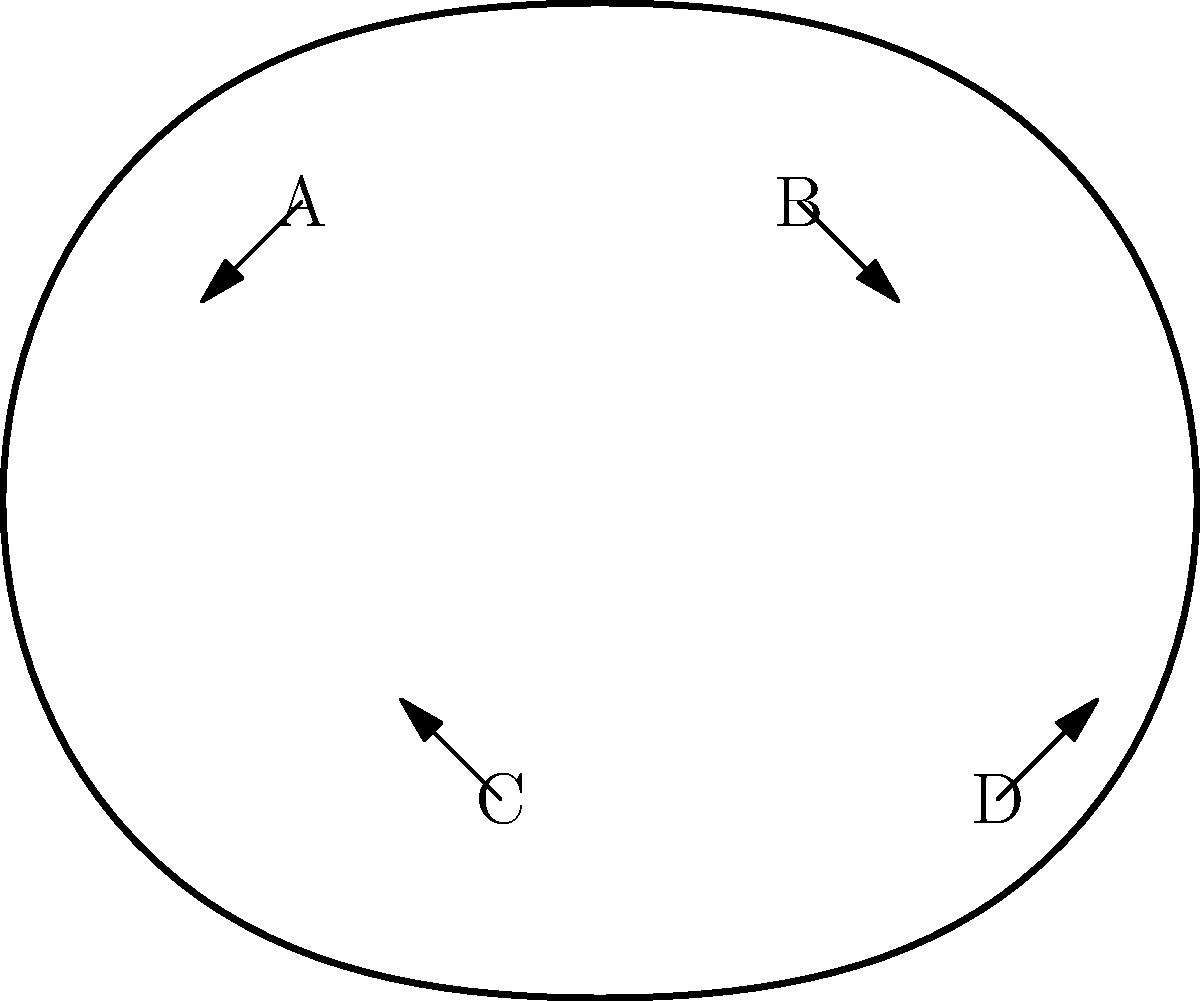Match the following mental health conditions with their associated brain regions in the diagram:

1. Depression
2. Anxiety
3. ADHD
4. Schizophrenia

Which letter (A, B, C, or D) corresponds to the brain region most associated with each condition? To answer this question, let's examine each mental health condition and its associated brain region:

1. Depression: primarily associated with the prefrontal cortex and limbic system, particularly the hippocampus. In the diagram, area A represents the prefrontal cortex.

2. Anxiety: mainly linked to the amygdala, which is part of the limbic system. In the diagram, area C represents the approximate location of the amygdala.

3. ADHD (Attention Deficit Hyperactivity Disorder): associated with the frontal lobe, specifically the prefrontal cortex. This is also represented by area A in the diagram.

4. Schizophrenia: involves multiple brain regions, but significant abnormalities are often found in the temporal lobe. In the diagram, area D represents the temporal lobe.

Step-by-step matching:
1. Depression - A (prefrontal cortex)
2. Anxiety - C (amygdala)
3. ADHD - A (prefrontal cortex)
4. Schizophrenia - D (temporal lobe)

Note that B, which represents the parietal lobe, is not primarily associated with any of the listed conditions in this simplified model.
Answer: 1-A, 2-C, 3-A, 4-D 